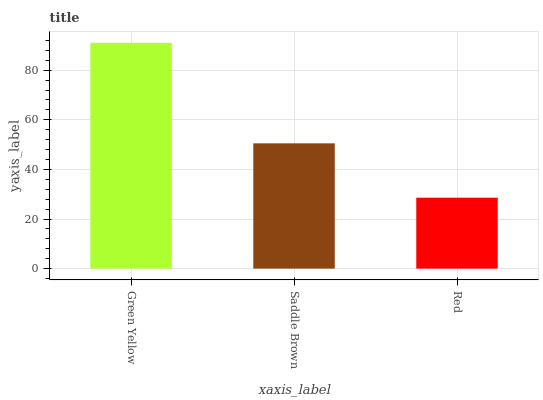Is Red the minimum?
Answer yes or no. Yes. Is Green Yellow the maximum?
Answer yes or no. Yes. Is Saddle Brown the minimum?
Answer yes or no. No. Is Saddle Brown the maximum?
Answer yes or no. No. Is Green Yellow greater than Saddle Brown?
Answer yes or no. Yes. Is Saddle Brown less than Green Yellow?
Answer yes or no. Yes. Is Saddle Brown greater than Green Yellow?
Answer yes or no. No. Is Green Yellow less than Saddle Brown?
Answer yes or no. No. Is Saddle Brown the high median?
Answer yes or no. Yes. Is Saddle Brown the low median?
Answer yes or no. Yes. Is Red the high median?
Answer yes or no. No. Is Red the low median?
Answer yes or no. No. 